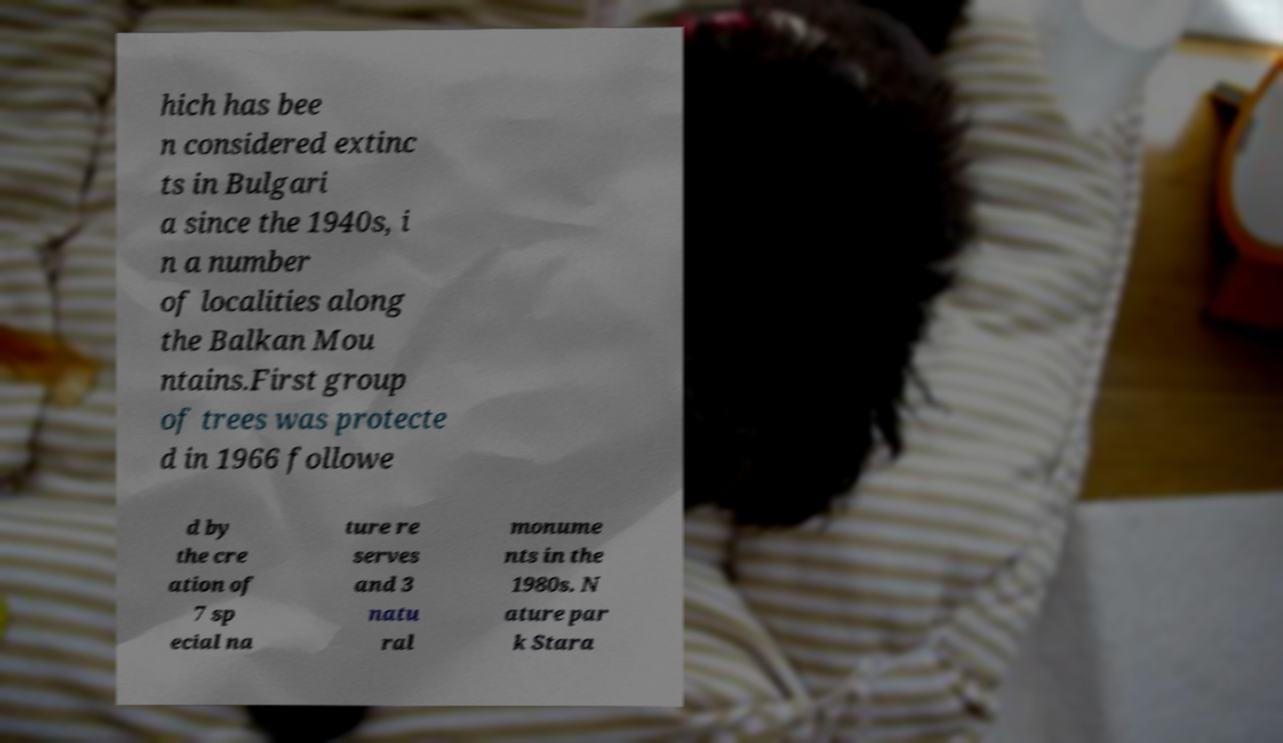There's text embedded in this image that I need extracted. Can you transcribe it verbatim? hich has bee n considered extinc ts in Bulgari a since the 1940s, i n a number of localities along the Balkan Mou ntains.First group of trees was protecte d in 1966 followe d by the cre ation of 7 sp ecial na ture re serves and 3 natu ral monume nts in the 1980s. N ature par k Stara 